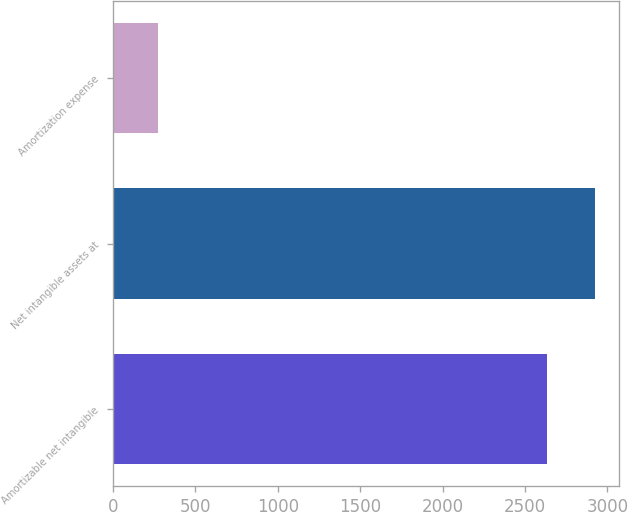Convert chart. <chart><loc_0><loc_0><loc_500><loc_500><bar_chart><fcel>Amortizable net intangible<fcel>Net intangible assets at<fcel>Amortization expense<nl><fcel>2632<fcel>2923.6<fcel>274<nl></chart> 